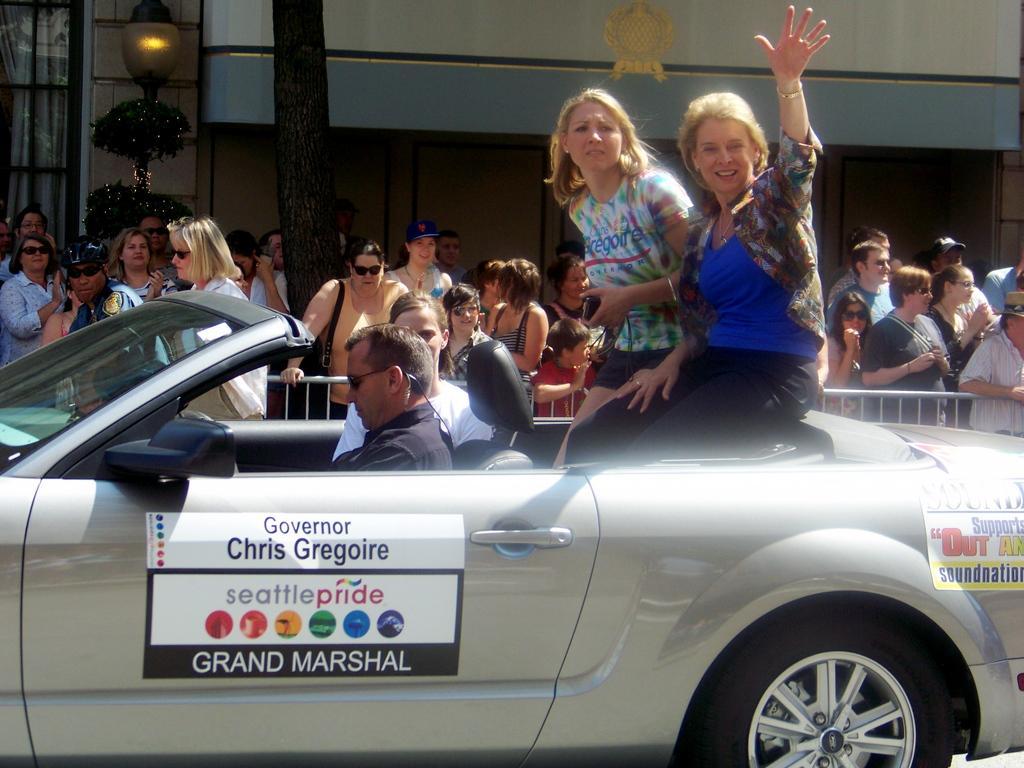Describe this image in one or two sentences. Here in this picture we can see a car. A man is driving car and two ladies are sitting at the back side of the car. And in the background we can see many people are standing and watching. And we can see a tree trunk. And also a lamp. A window with white curtain. A brick wall and a pillar. 